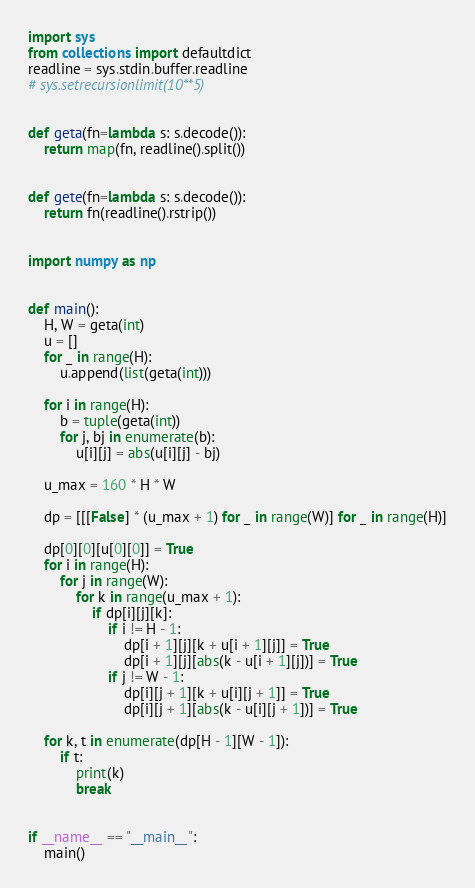<code> <loc_0><loc_0><loc_500><loc_500><_Python_>import sys
from collections import defaultdict
readline = sys.stdin.buffer.readline
# sys.setrecursionlimit(10**5)


def geta(fn=lambda s: s.decode()):
    return map(fn, readline().split())


def gete(fn=lambda s: s.decode()):
    return fn(readline().rstrip())


import numpy as np


def main():
    H, W = geta(int)
    u = []
    for _ in range(H):
        u.append(list(geta(int)))

    for i in range(H):
        b = tuple(geta(int))
        for j, bj in enumerate(b):
            u[i][j] = abs(u[i][j] - bj)

    u_max = 160 * H * W

    dp = [[[False] * (u_max + 1) for _ in range(W)] for _ in range(H)]

    dp[0][0][u[0][0]] = True
    for i in range(H):
        for j in range(W):
            for k in range(u_max + 1):
                if dp[i][j][k]:
                    if i != H - 1:
                        dp[i + 1][j][k + u[i + 1][j]] = True
                        dp[i + 1][j][abs(k - u[i + 1][j])] = True
                    if j != W - 1:
                        dp[i][j + 1][k + u[i][j + 1]] = True
                        dp[i][j + 1][abs(k - u[i][j + 1])] = True

    for k, t in enumerate(dp[H - 1][W - 1]):
        if t:
            print(k)
            break


if __name__ == "__main__":
    main()</code> 